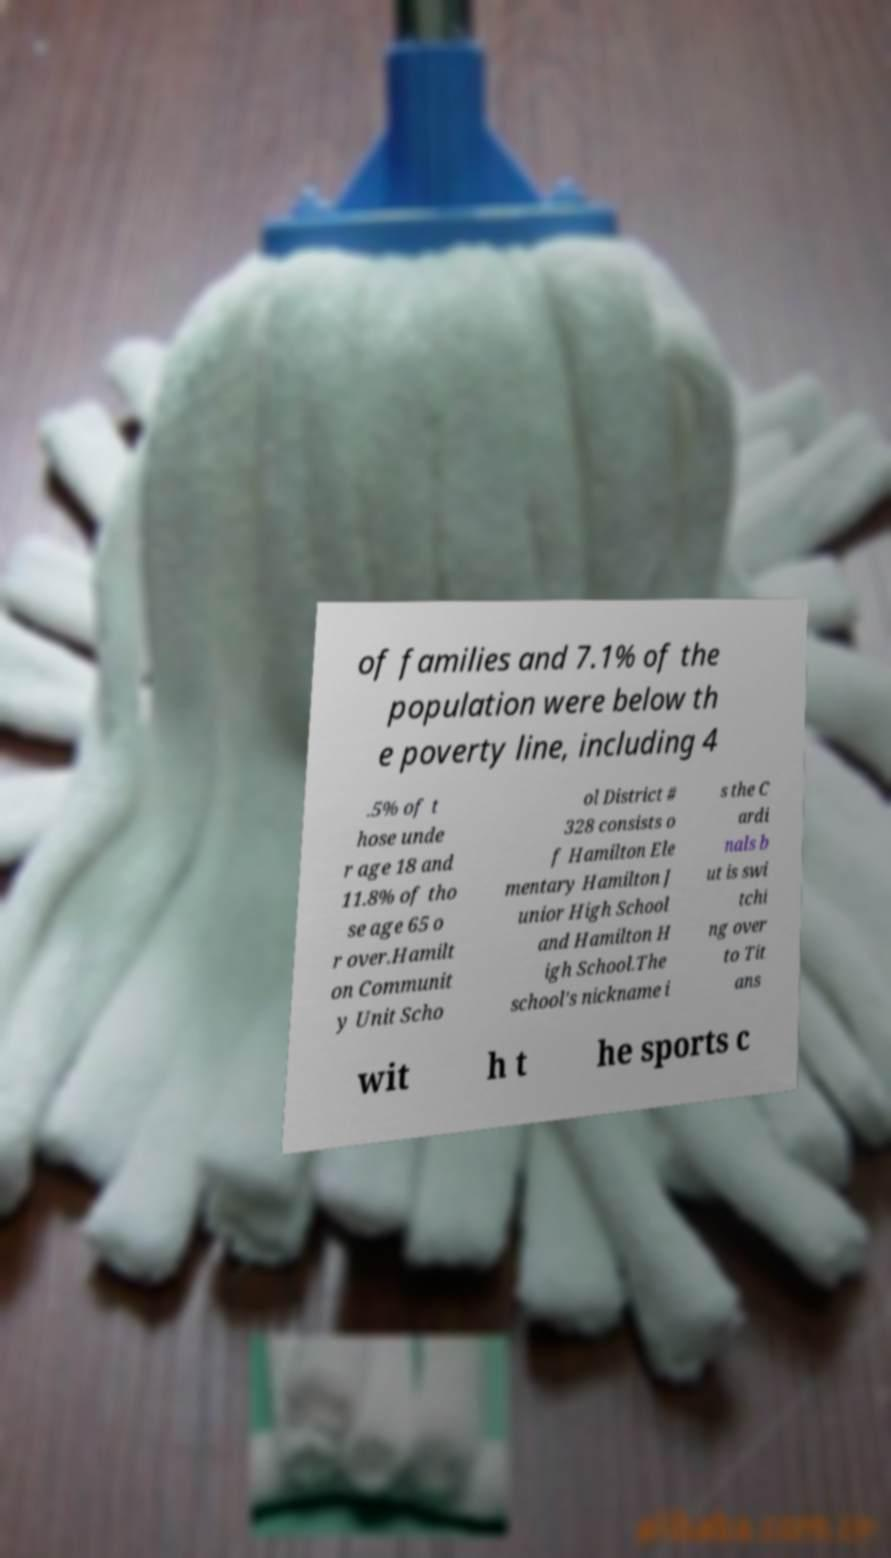Please identify and transcribe the text found in this image. of families and 7.1% of the population were below th e poverty line, including 4 .5% of t hose unde r age 18 and 11.8% of tho se age 65 o r over.Hamilt on Communit y Unit Scho ol District # 328 consists o f Hamilton Ele mentary Hamilton J unior High School and Hamilton H igh School.The school's nickname i s the C ardi nals b ut is swi tchi ng over to Tit ans wit h t he sports c 